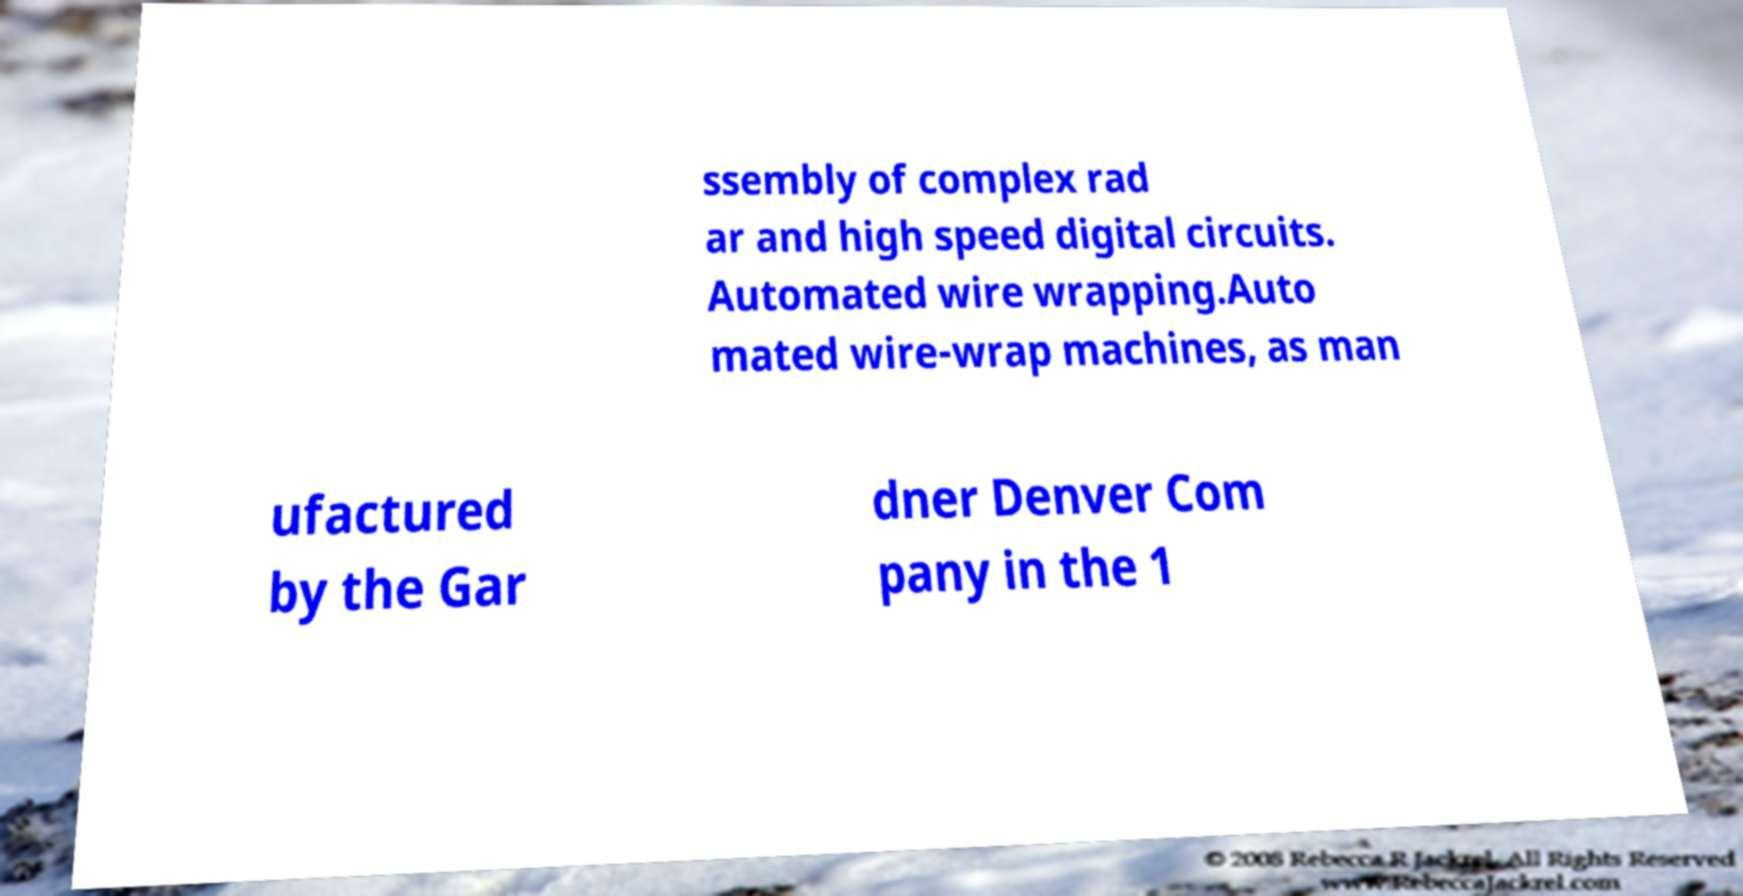Please identify and transcribe the text found in this image. ssembly of complex rad ar and high speed digital circuits. Automated wire wrapping.Auto mated wire-wrap machines, as man ufactured by the Gar dner Denver Com pany in the 1 